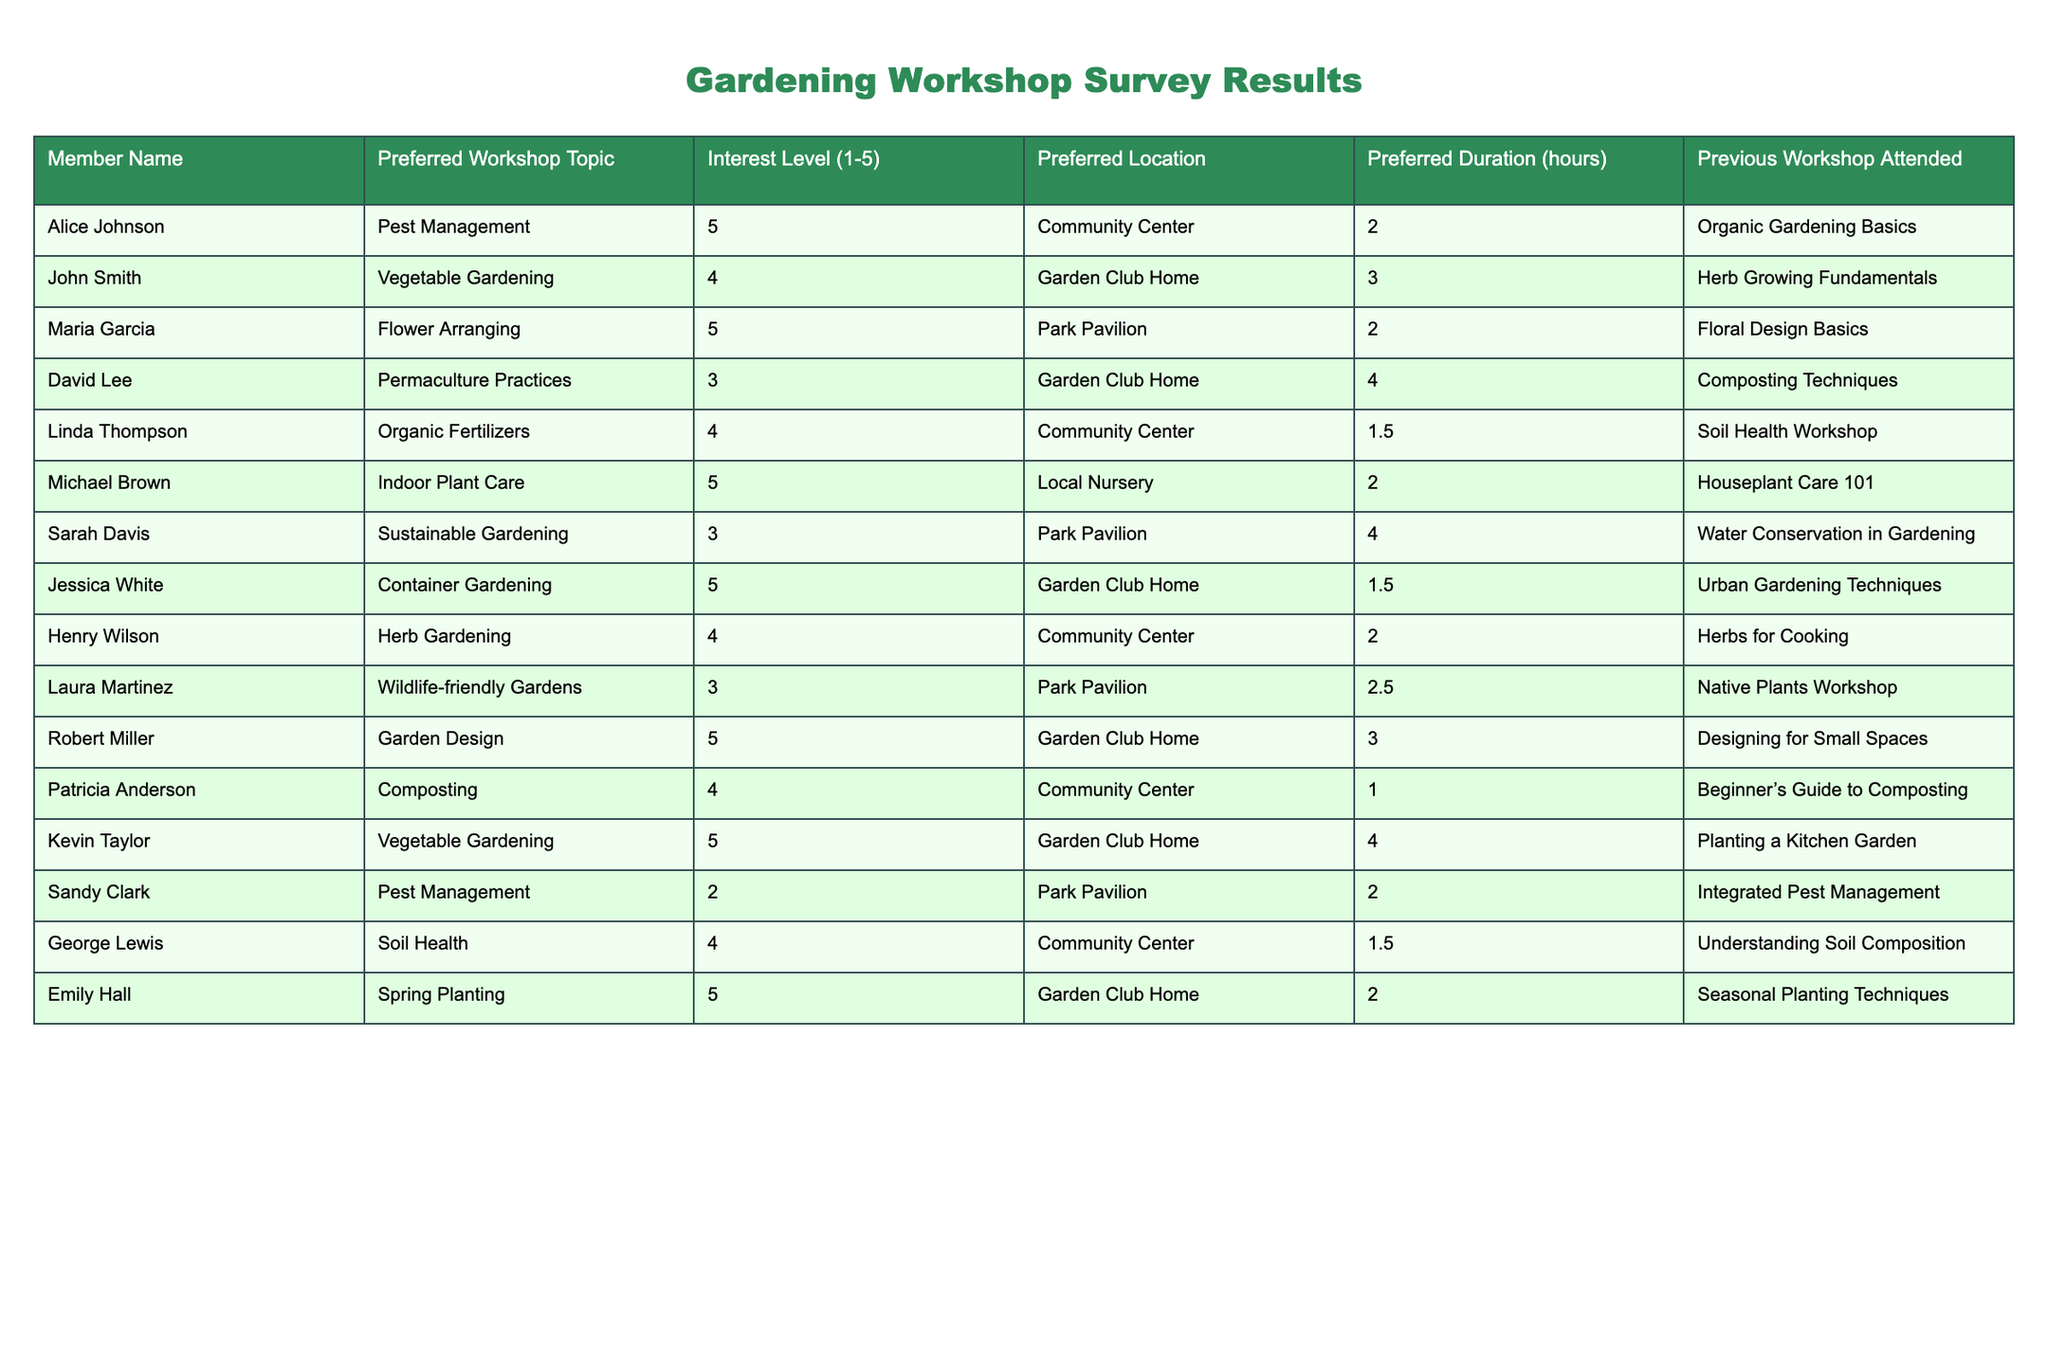What is the preferred workshop topic for Alice Johnson? Alice Johnson’s preferred workshop topic is listed in the second column of the table. According to the data, it is "Pest Management."
Answer: Pest Management How many members have an interest level of 5? To find the number of members with an interest level of 5, we count the entries in the "Interest Level" column that are equal to 5. The members with this interest level are Alice Johnson, Maria Garcia, Michael Brown, Jessica White, Robert Miller, Kevin Taylor, and Emily Hall, totaling 7 members.
Answer: 7 What is the preferred location for David Lee's workshop? The preferred location for David Lee's workshop can be found in the "Preferred Location" column next to his name in the table. It is "Garden Club Home."
Answer: Garden Club Home Is there any member who prefers a workshop duration of 1 hour? By checking the "Preferred Duration" column, we see that Patricia Anderson has a preferred duration of 1 hour, indicating that yes, there is a member with this preference.
Answer: Yes What is the average interest level of the members who prefer "Vegetable Gardening"? First, identify the members interested in "Vegetable Gardening" from the "Preferred Workshop Topic" column: John Smith and Kevin Taylor. Their interest levels are 4 and 5 respectively. To find the average, sum these values (4 + 5 = 9) and divide by the number of members (2), resulting in an average interest level of 4.5.
Answer: 4.5 Which workshop topic has the highest interest level based on the survey? Review the "Interest Level" column for each workshop topic. The highest interest level of 5 appears for topics: Pest Management, Flower Arranging, Indoor Plant Care, Container Gardening, Garden Design, Vegetable Gardening, and Spring Planting. Therefore, multiple topics share the highest level.
Answer: Pest Management, Flower Arranging, Indoor Plant Care, Container Gardening, Garden Design, Vegetable Gardening, Spring Planting How many members expressed greater than or equal to 4 in their interest level? Count members with interest levels of 4 or 5 from the "Interest Level" column. The following members meet this criterion: Alice Johnson, John Smith, Maria Garcia, Linda Thompson, Michael Brown, Jessica White, Henry Wilson, Robert Miller, Kevin Taylor, Patricia Anderson, and Emily Hall. This totals 11 members.
Answer: 11 What is the most common preferred location among members? To determine the most common preferred location, we can tally the occurrences in the "Preferred Location" column. The counts are: Community Center (4), Garden Club Home (4), and Park Pavilion (3). Both Community Center and Garden Club Home have the highest counts, with 4 each.
Answer: Community Center, Garden Club Home Do any members prefer a workshop duration longer than 3 hours? Check the "Preferred Duration" column for values greater than 3. David Lee and Kevin Taylor have preferred durations of 4 hours, indicating that yes, there are members who prefer a longer duration.
Answer: Yes What is the range of preferred durations for workshops considered in the survey? The "Preferred Duration" values are 1, 1.5, 2, 2.5, 3, and 4 hours. The smallest duration is 1 hour and the largest is 4 hours. The range is calculated by subtracting the smallest value from the largest, which is 4 - 1 = 3.
Answer: 3 